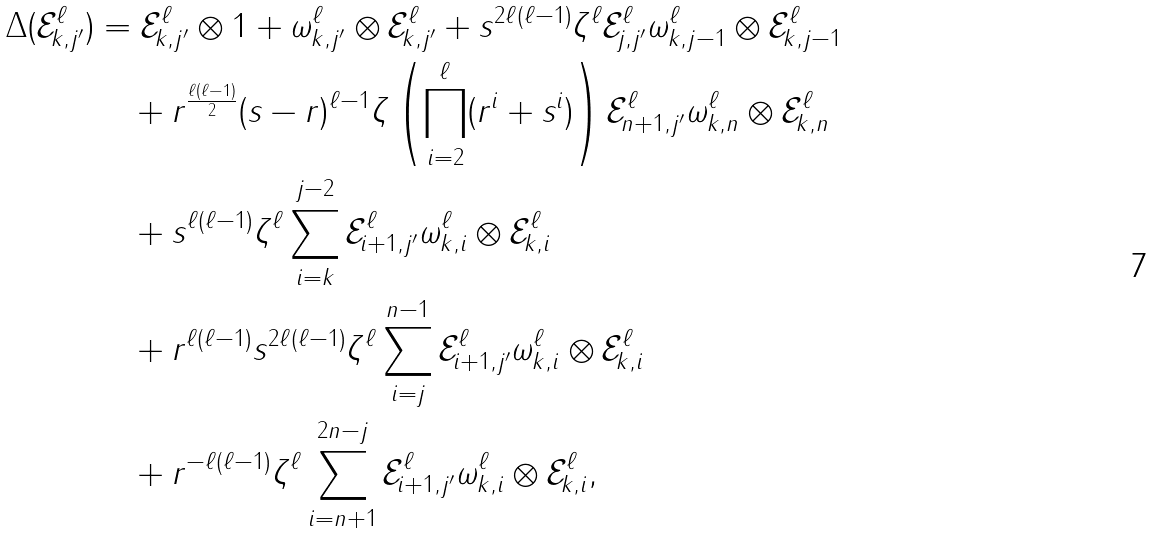<formula> <loc_0><loc_0><loc_500><loc_500>\Delta ( \mathcal { E } _ { k , j ^ { \prime } } ^ { \ell } ) & = \mathcal { E } _ { k , j ^ { \prime } } ^ { \ell } \otimes 1 + \omega _ { k , j ^ { \prime } } ^ { \ell } \otimes \mathcal { E } _ { k , j ^ { \prime } } ^ { \ell } + s ^ { 2 \ell ( \ell - 1 ) } \zeta ^ { \ell } \mathcal { E } _ { j , j ^ { \prime } } ^ { \ell } \omega _ { k , j - 1 } ^ { \ell } \otimes \mathcal { E } _ { k , j - 1 } ^ { \ell } \\ & \quad + r ^ { \frac { \ell ( \ell - 1 ) } { 2 } } ( s - r ) ^ { \ell - 1 } \zeta \left ( \prod _ { i = 2 } ^ { \ell } ( r ^ { i } + s ^ { i } ) \right ) \mathcal { E } _ { n + 1 , j ^ { \prime } } ^ { \ell } \omega _ { k , n } ^ { \ell } \otimes \mathcal { E } _ { k , n } ^ { \ell } \\ & \quad + s ^ { \ell ( \ell - 1 ) } \zeta ^ { \ell } \sum _ { i = k } ^ { j - 2 } \mathcal { E } _ { i + 1 , j ^ { \prime } } ^ { \ell } \omega _ { k , i } ^ { \ell } \otimes \mathcal { E } _ { k , i } ^ { \ell } \\ & \quad + r ^ { \ell ( \ell - 1 ) } s ^ { 2 \ell ( \ell - 1 ) } \zeta ^ { \ell } \sum _ { i = j } ^ { n - 1 } \mathcal { E } _ { i + 1 , j ^ { \prime } } ^ { \ell } \omega _ { k , i } ^ { \ell } \otimes \mathcal { E } _ { k , i } ^ { \ell } \\ & \quad + r ^ { - \ell ( \ell - 1 ) } \zeta ^ { \ell } \sum _ { i = n + 1 } ^ { 2 n - j } \mathcal { E } _ { i + 1 , j ^ { \prime } } ^ { \ell } \omega _ { k , i } ^ { \ell } \otimes \mathcal { E } _ { k , i } ^ { \ell } ,</formula> 